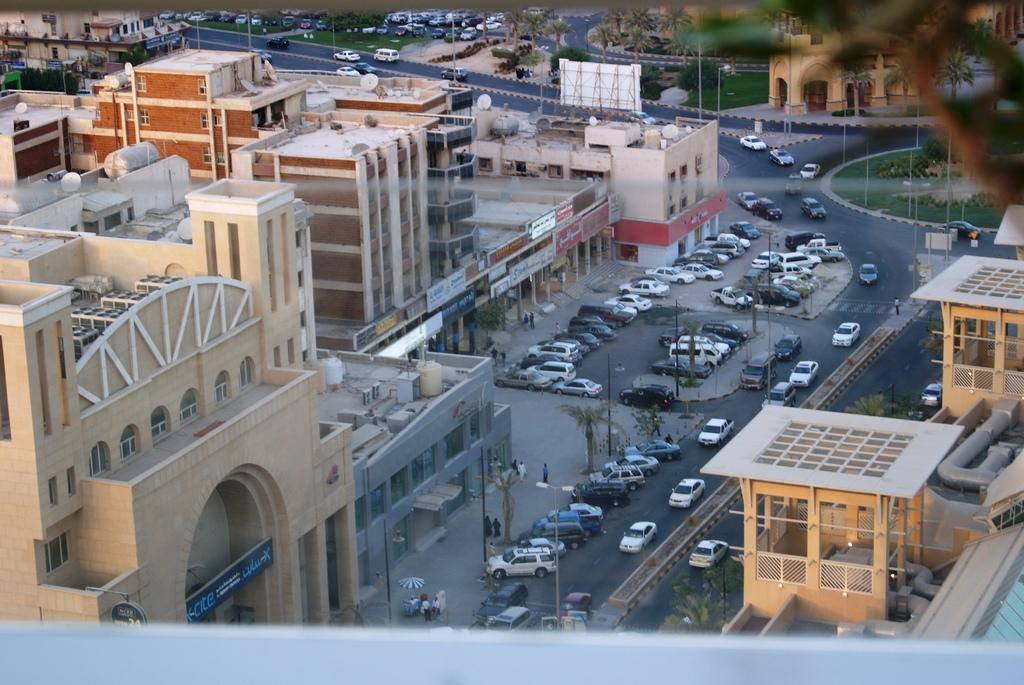Can you describe this image briefly? In the picture I can see few buildings,vehicles and trees. 